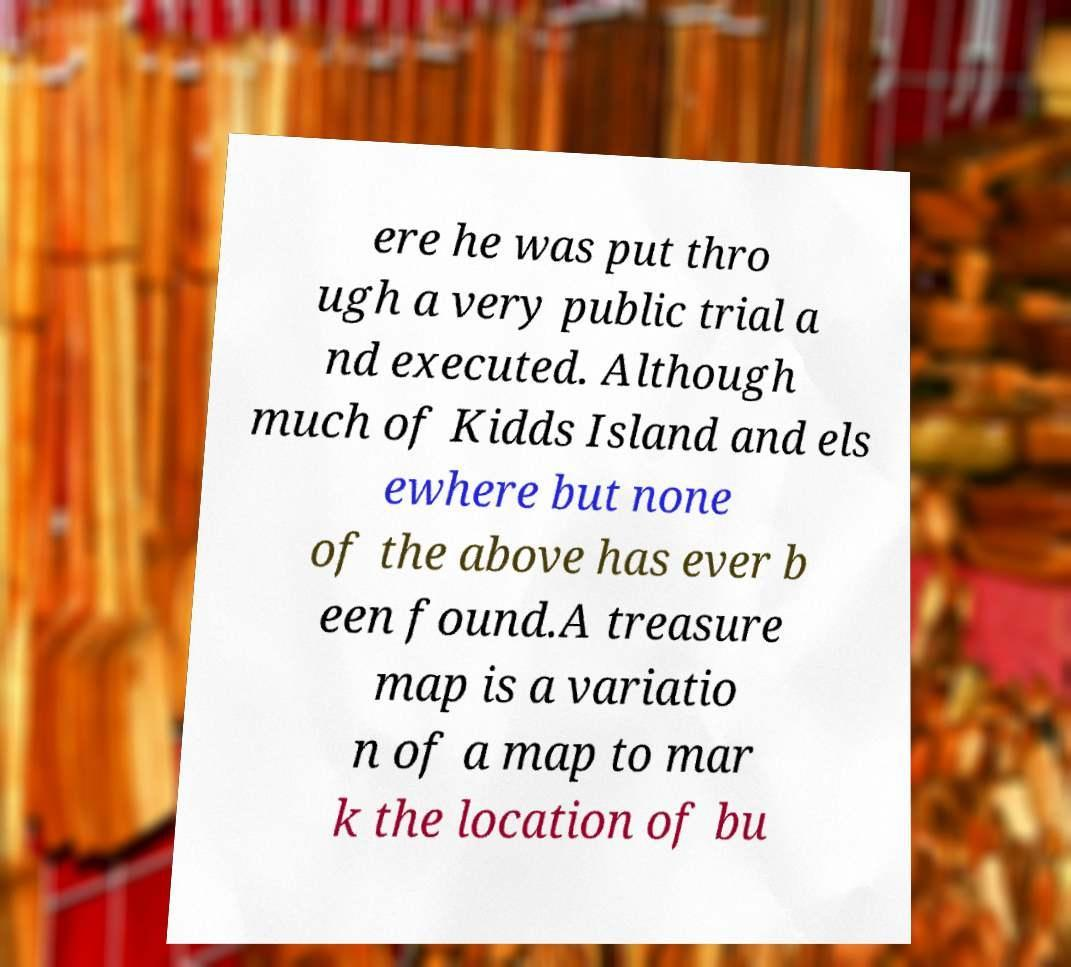Please read and relay the text visible in this image. What does it say? ere he was put thro ugh a very public trial a nd executed. Although much of Kidds Island and els ewhere but none of the above has ever b een found.A treasure map is a variatio n of a map to mar k the location of bu 